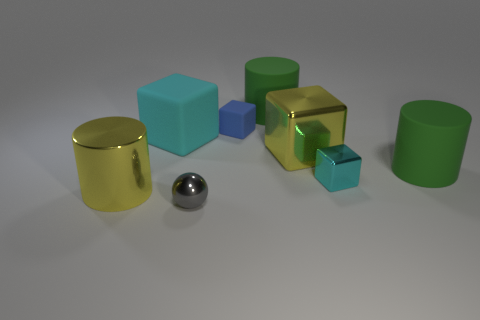What textures can be observed on the surfaces of the objects? The objects exhibit a variety of textures: the cylindrical containers have a shiny, reflective surface, while the cubes and blocks appear to have a more matte finish, accentuating their solid colors. 